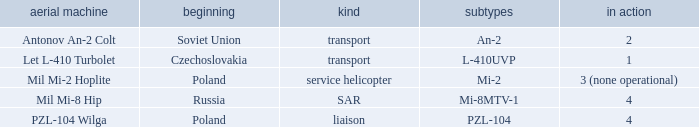Tell me the versions for czechoslovakia? L-410UVP. Would you be able to parse every entry in this table? {'header': ['aerial machine', 'beginning', 'kind', 'subtypes', 'in action'], 'rows': [['Antonov An-2 Colt', 'Soviet Union', 'transport', 'An-2', '2'], ['Let L-410 Turbolet', 'Czechoslovakia', 'transport', 'L-410UVP', '1'], ['Mil Mi-2 Hoplite', 'Poland', 'service helicopter', 'Mi-2', '3 (none operational)'], ['Mil Mi-8 Hip', 'Russia', 'SAR', 'Mi-8MTV-1', '4'], ['PZL-104 Wilga', 'Poland', 'liaison', 'PZL-104', '4']]} 